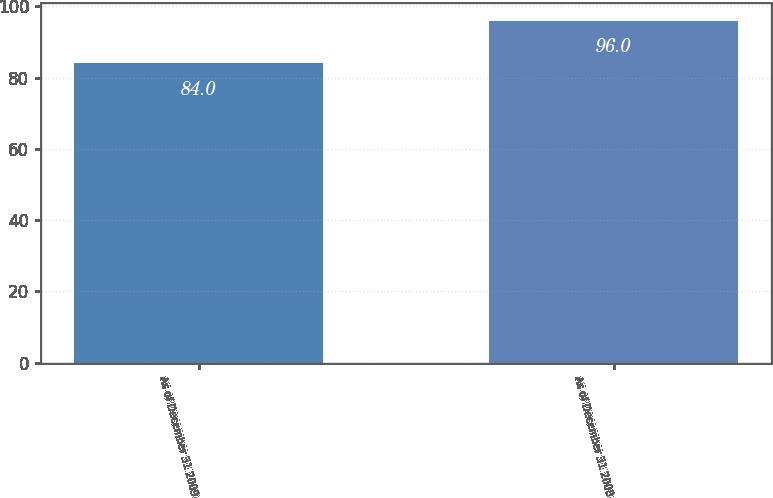Convert chart. <chart><loc_0><loc_0><loc_500><loc_500><bar_chart><fcel>As of December 31 2009<fcel>As of December 31 2008<nl><fcel>84<fcel>96<nl></chart> 